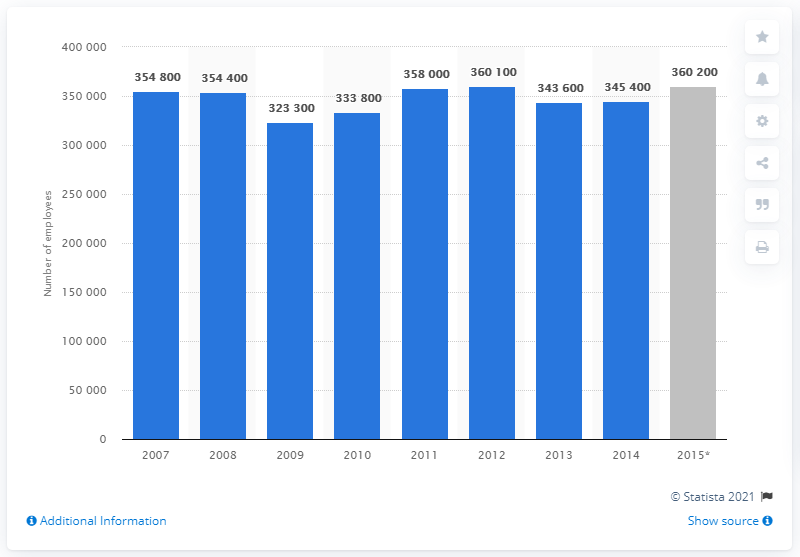Mention a couple of crucial points in this snapshot. In 2014, there were approximately 345,400 people employed in the financial services sector in London. In June 2015, there were approximately 360,200 financial services sector employees working in London. 